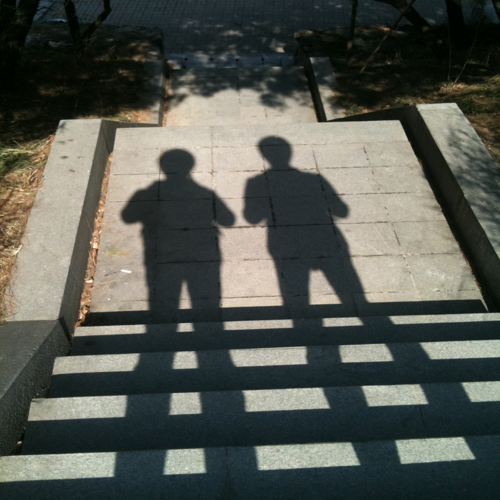What can we infer about the location depicted in the image? Based on the appearance of the steps and the shadows, it seems to be an outdoor urban setting, possibly a park or a pedestrian area. The materials and construction are typical for public outdoor spaces. 